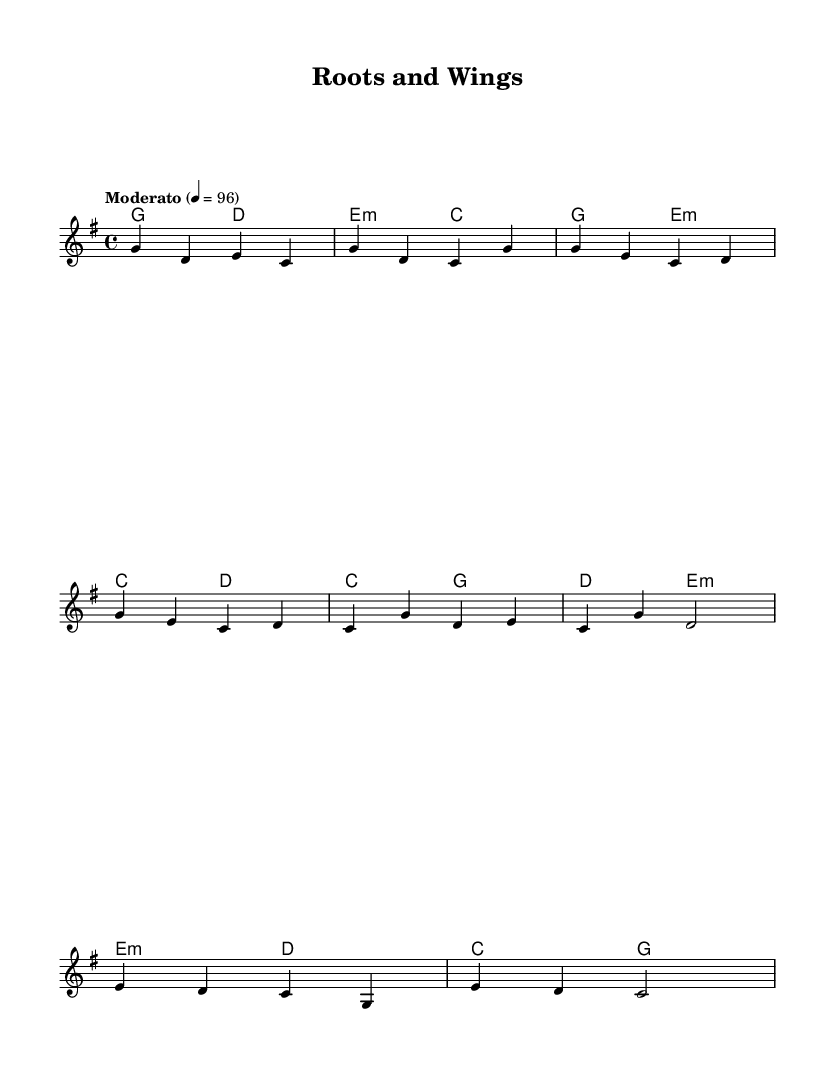What is the time signature of this music? The time signature is indicated at the beginning of the score, shown as "4/4", which means there are four beats in each measure.
Answer: 4/4 What key is this music composed in? The key signature is shown at the beginning of the score and there are no sharps or flats, indicating it is in G major.
Answer: G major What is the tempo marking of this piece? The tempo marking is found above the staff, stating "Moderato" with a speed indication of 4 equals 96 beats per minute.
Answer: Moderato How many measures does the melody contain in the introduction? The introduction contains two measures, identifiable by the lines before the first verse starts, and is marked accordingly in the notation.
Answer: 2 What chords are used in the chorus? In the chorus, the chords are written as "C, G, D, E minor", which can be found noted above the melody line in the respective measures.
Answer: C, G, D, E minor What is the highest note in the melody? The highest note in the melody can be identified by looking for the note furthest up the staff, which in this case is "G prime".
Answer: G prime What type of music fusion does this piece represent? The music is classified as an "Indie folk-world music fusion" based on its characteristics of blending folk elements with contemporary indie styles, which is often reflected in its melodies and harmonies.
Answer: Indie folk-world music fusion 